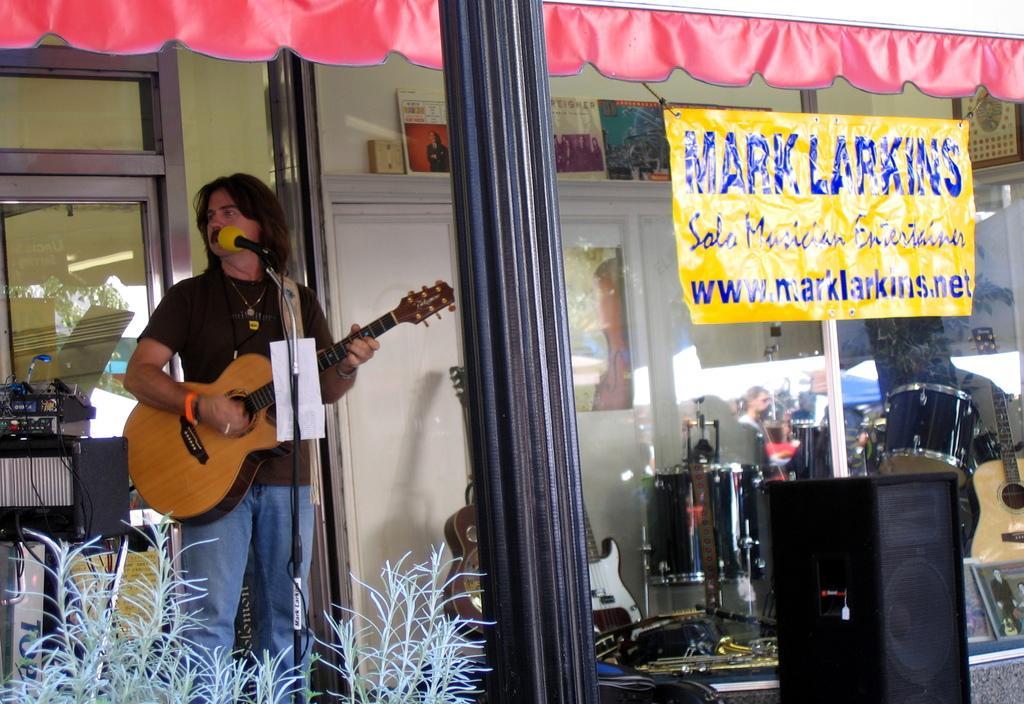In one or two sentences, can you explain what this image depicts? Here we can one man standing in front of a mike and playing guitar. We can see all the musical instruments through a glass. This is a poster. This is a plant. 